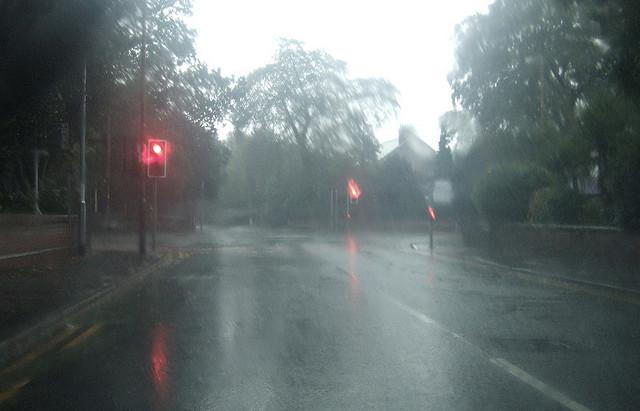Is it a clear sunny day?
Answer briefly. No. Is it night time?
Concise answer only. No. Is it raining?
Short answer required. Yes. Is a driver supposed to stop?
Keep it brief. Yes. 